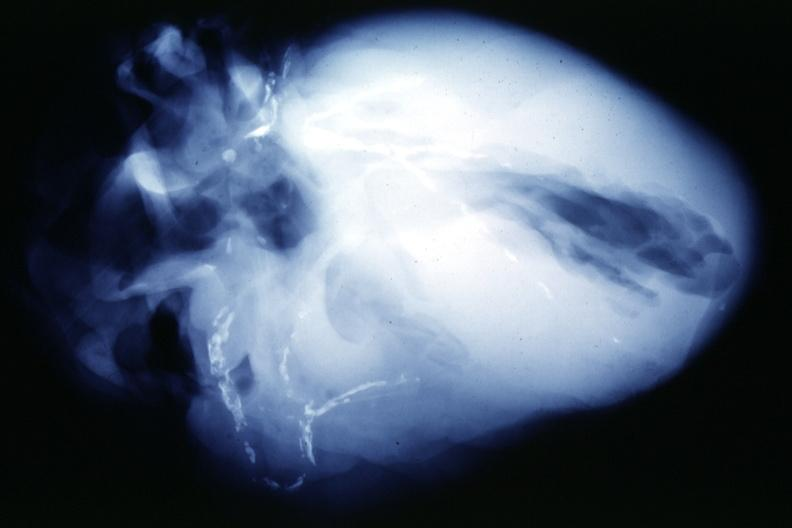does this image show x-ray postmortextensive lesions in this x-ray of whole heart?
Answer the question using a single word or phrase. Yes 